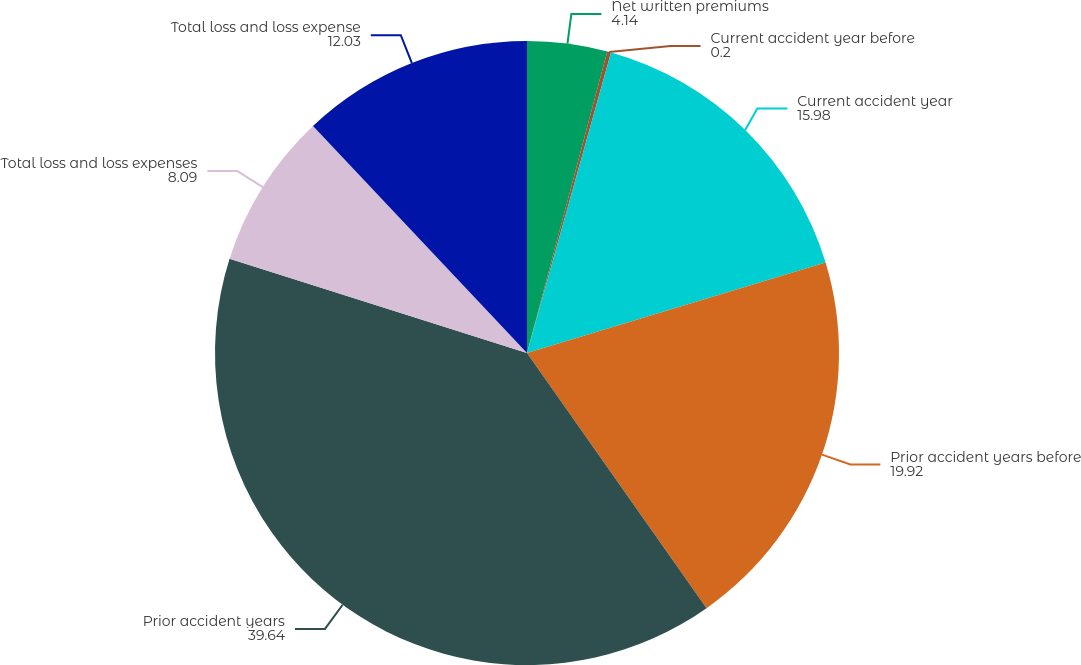Convert chart to OTSL. <chart><loc_0><loc_0><loc_500><loc_500><pie_chart><fcel>Net written premiums<fcel>Current accident year before<fcel>Current accident year<fcel>Prior accident years before<fcel>Prior accident years<fcel>Total loss and loss expenses<fcel>Total loss and loss expense<nl><fcel>4.14%<fcel>0.2%<fcel>15.98%<fcel>19.92%<fcel>39.64%<fcel>8.09%<fcel>12.03%<nl></chart> 